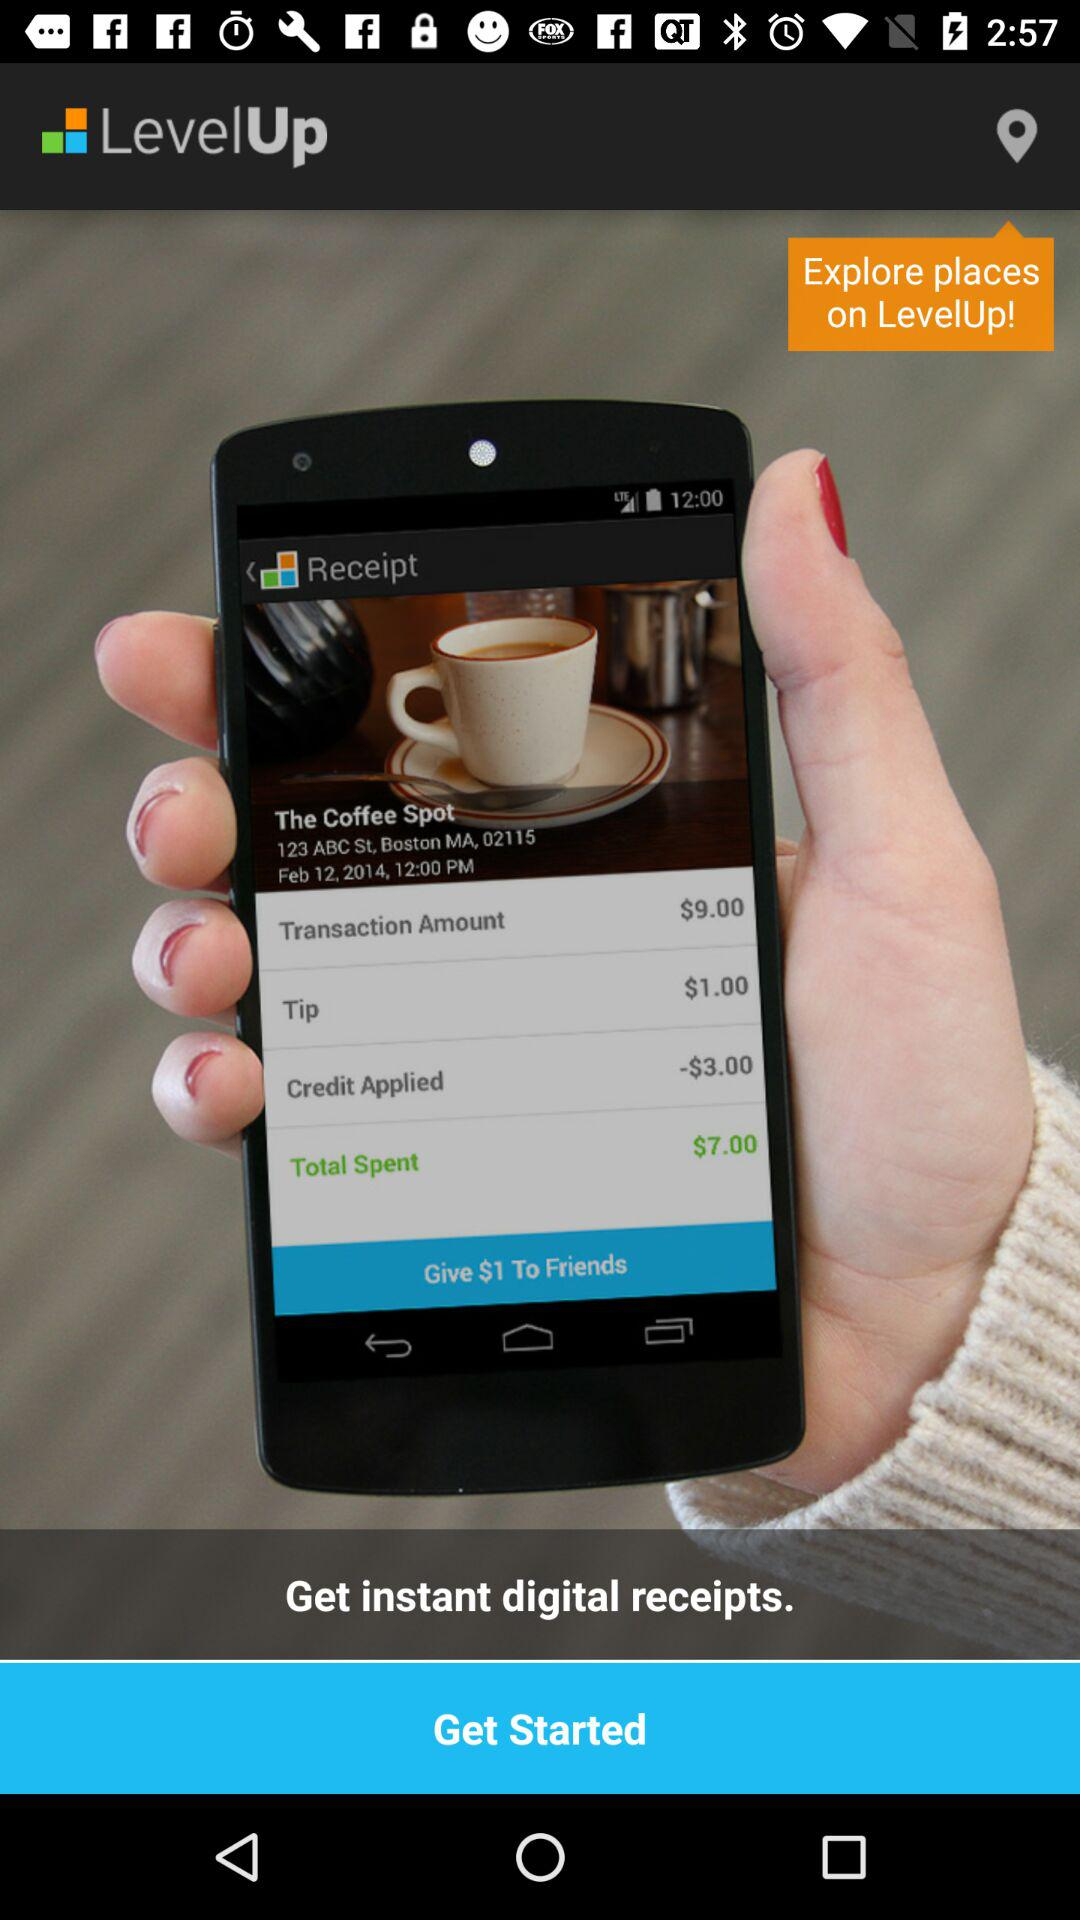What is the application name? The application name is "LevelUp". 